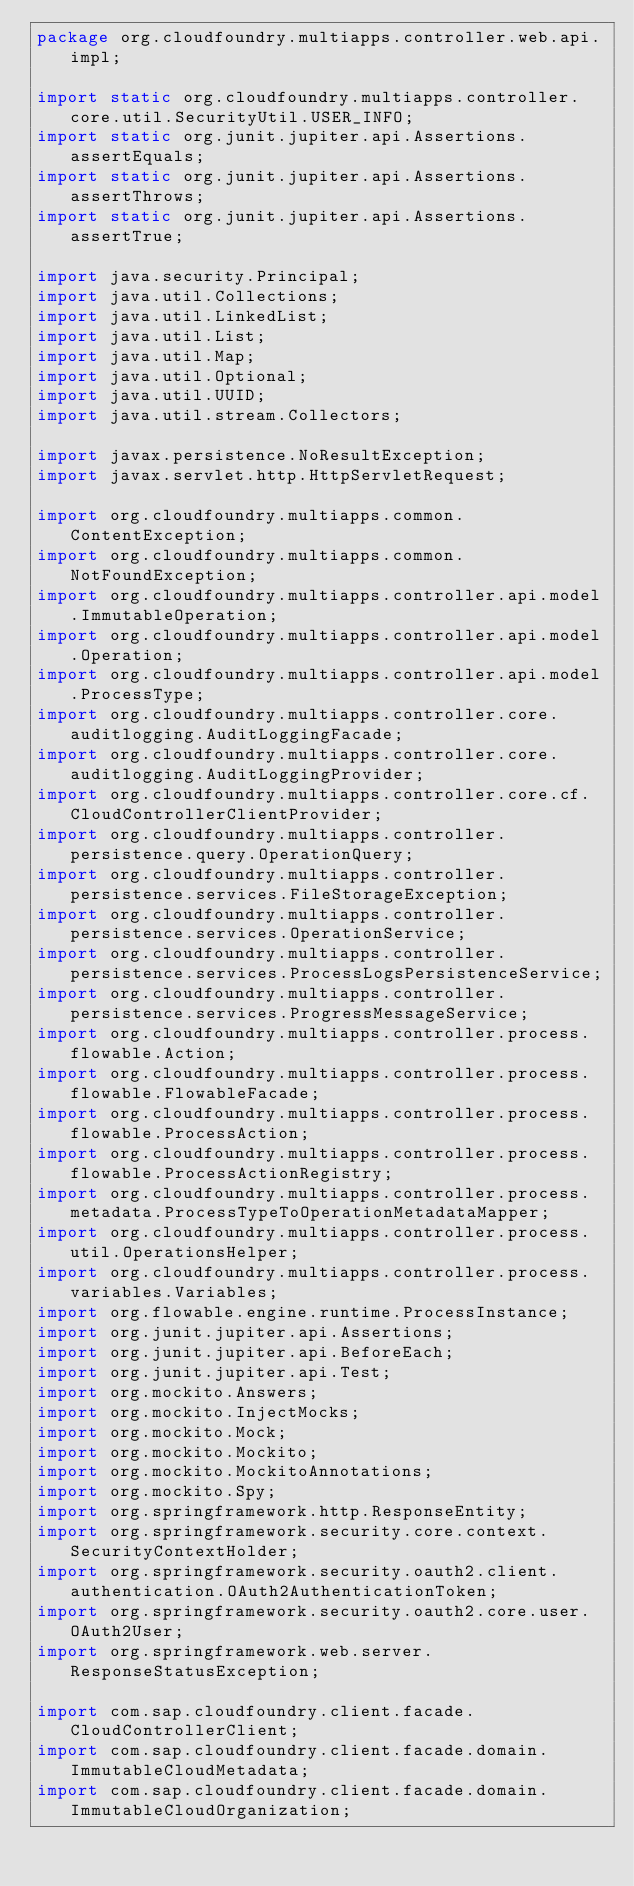<code> <loc_0><loc_0><loc_500><loc_500><_Java_>package org.cloudfoundry.multiapps.controller.web.api.impl;

import static org.cloudfoundry.multiapps.controller.core.util.SecurityUtil.USER_INFO;
import static org.junit.jupiter.api.Assertions.assertEquals;
import static org.junit.jupiter.api.Assertions.assertThrows;
import static org.junit.jupiter.api.Assertions.assertTrue;

import java.security.Principal;
import java.util.Collections;
import java.util.LinkedList;
import java.util.List;
import java.util.Map;
import java.util.Optional;
import java.util.UUID;
import java.util.stream.Collectors;

import javax.persistence.NoResultException;
import javax.servlet.http.HttpServletRequest;

import org.cloudfoundry.multiapps.common.ContentException;
import org.cloudfoundry.multiapps.common.NotFoundException;
import org.cloudfoundry.multiapps.controller.api.model.ImmutableOperation;
import org.cloudfoundry.multiapps.controller.api.model.Operation;
import org.cloudfoundry.multiapps.controller.api.model.ProcessType;
import org.cloudfoundry.multiapps.controller.core.auditlogging.AuditLoggingFacade;
import org.cloudfoundry.multiapps.controller.core.auditlogging.AuditLoggingProvider;
import org.cloudfoundry.multiapps.controller.core.cf.CloudControllerClientProvider;
import org.cloudfoundry.multiapps.controller.persistence.query.OperationQuery;
import org.cloudfoundry.multiapps.controller.persistence.services.FileStorageException;
import org.cloudfoundry.multiapps.controller.persistence.services.OperationService;
import org.cloudfoundry.multiapps.controller.persistence.services.ProcessLogsPersistenceService;
import org.cloudfoundry.multiapps.controller.persistence.services.ProgressMessageService;
import org.cloudfoundry.multiapps.controller.process.flowable.Action;
import org.cloudfoundry.multiapps.controller.process.flowable.FlowableFacade;
import org.cloudfoundry.multiapps.controller.process.flowable.ProcessAction;
import org.cloudfoundry.multiapps.controller.process.flowable.ProcessActionRegistry;
import org.cloudfoundry.multiapps.controller.process.metadata.ProcessTypeToOperationMetadataMapper;
import org.cloudfoundry.multiapps.controller.process.util.OperationsHelper;
import org.cloudfoundry.multiapps.controller.process.variables.Variables;
import org.flowable.engine.runtime.ProcessInstance;
import org.junit.jupiter.api.Assertions;
import org.junit.jupiter.api.BeforeEach;
import org.junit.jupiter.api.Test;
import org.mockito.Answers;
import org.mockito.InjectMocks;
import org.mockito.Mock;
import org.mockito.Mockito;
import org.mockito.MockitoAnnotations;
import org.mockito.Spy;
import org.springframework.http.ResponseEntity;
import org.springframework.security.core.context.SecurityContextHolder;
import org.springframework.security.oauth2.client.authentication.OAuth2AuthenticationToken;
import org.springframework.security.oauth2.core.user.OAuth2User;
import org.springframework.web.server.ResponseStatusException;

import com.sap.cloudfoundry.client.facade.CloudControllerClient;
import com.sap.cloudfoundry.client.facade.domain.ImmutableCloudMetadata;
import com.sap.cloudfoundry.client.facade.domain.ImmutableCloudOrganization;</code> 